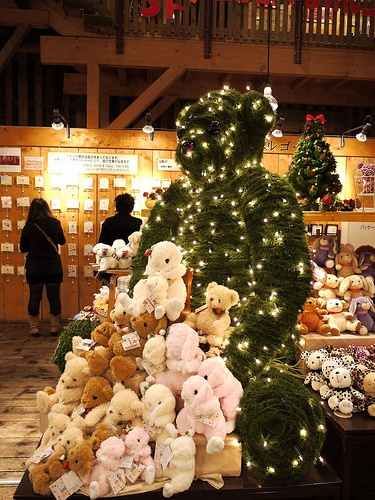Describe the objects in this image and their specific colors. I can see teddy bear in black and tan tones, people in black, maroon, and brown tones, teddy bear in black, brown, maroon, orange, and tan tones, teddy bear in black, tan, and red tones, and teddy bear in black, tan, and red tones in this image. 